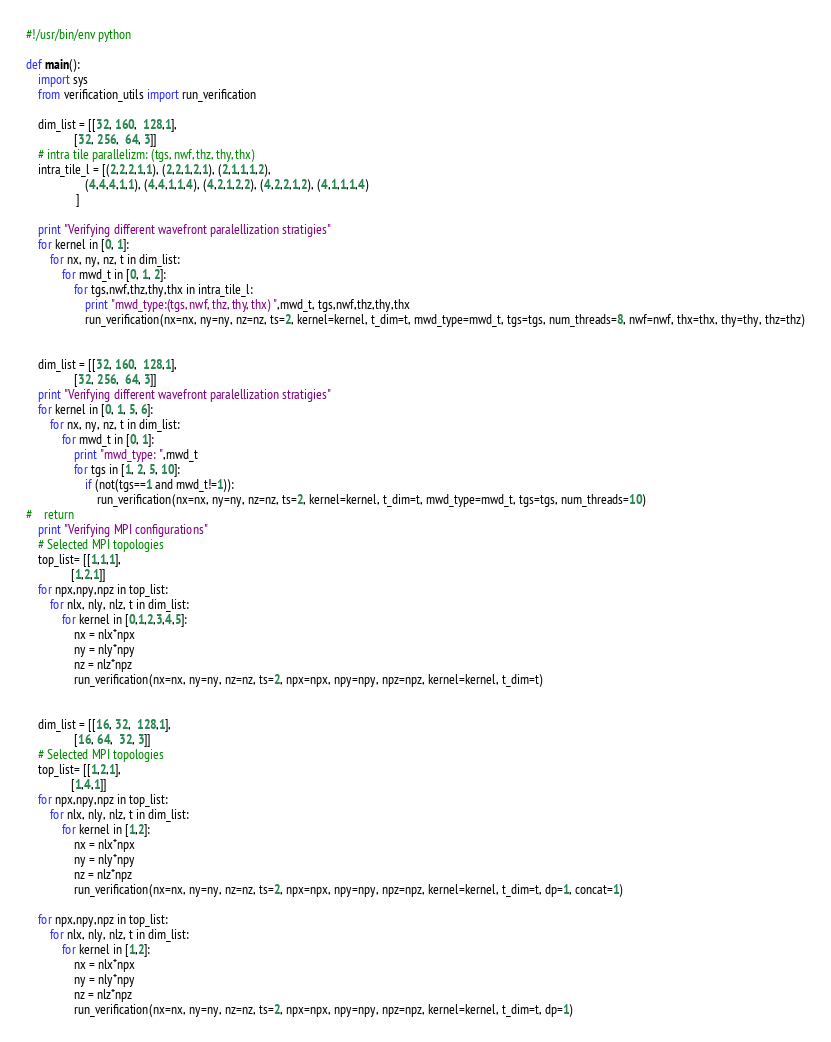<code> <loc_0><loc_0><loc_500><loc_500><_Python_>#!/usr/bin/env python

def main():
    import sys
    from verification_utils import run_verification

    dim_list = [[32, 160,  128,1],
                [32, 256,  64, 3]]
    # intra tile parallelizm: (tgs, nwf, thz, thy, thx)
    intra_tile_l = [(2,2,2,1,1), (2,2,1,2,1), (2,1,1,1,2),
                    (4,4,4,1,1), (4,4,1,1,4), (4,2,1,2,2), (4,2,2,1,2), (4,1,1,1,4)
                 ]

    print "Verifying different wavefront paralellization stratigies" 
    for kernel in [0, 1]:
        for nx, ny, nz, t in dim_list:
            for mwd_t in [0, 1, 2]:
                for tgs,nwf,thz,thy,thx in intra_tile_l:
                    print "mwd_type:(tgs, nwf, thz, thy, thx) ",mwd_t, tgs,nwf,thz,thy,thx
                    run_verification(nx=nx, ny=ny, nz=nz, ts=2, kernel=kernel, t_dim=t, mwd_type=mwd_t, tgs=tgs, num_threads=8, nwf=nwf, thx=thx, thy=thy, thz=thz)


    dim_list = [[32, 160,  128,1],
                [32, 256,  64, 3]]
    print "Verifying different wavefront paralellization stratigies" 
    for kernel in [0, 1, 5, 6]:
        for nx, ny, nz, t in dim_list:
            for mwd_t in [0, 1]:
                print "mwd_type: ",mwd_t
                for tgs in [1, 2, 5, 10]:
                    if (not(tgs==1 and mwd_t!=1)):
                        run_verification(nx=nx, ny=ny, nz=nz, ts=2, kernel=kernel, t_dim=t, mwd_type=mwd_t, tgs=tgs, num_threads=10)
#    return
    print "Verifying MPI configurations"
    # Selected MPI topologies
    top_list= [[1,1,1],
               [1,2,1]]
    for npx,npy,npz in top_list:
        for nlx, nly, nlz, t in dim_list:
            for kernel in [0,1,2,3,4,5]:
                nx = nlx*npx
                ny = nly*npy
                nz = nlz*npz
                run_verification(nx=nx, ny=ny, nz=nz, ts=2, npx=npx, npy=npy, npz=npz, kernel=kernel, t_dim=t)


    dim_list = [[16, 32,  128,1],
                [16, 64,  32, 3]]
    # Selected MPI topologies
    top_list= [[1,2,1],
               [1,4,1]]
    for npx,npy,npz in top_list:
        for nlx, nly, nlz, t in dim_list:
            for kernel in [1,2]:
                nx = nlx*npx
                ny = nly*npy
                nz = nlz*npz
                run_verification(nx=nx, ny=ny, nz=nz, ts=2, npx=npx, npy=npy, npz=npz, kernel=kernel, t_dim=t, dp=1, concat=1)

    for npx,npy,npz in top_list:
        for nlx, nly, nlz, t in dim_list:
            for kernel in [1,2]:
                nx = nlx*npx
                ny = nly*npy
                nz = nlz*npz
                run_verification(nx=nx, ny=ny, nz=nz, ts=2, npx=npx, npy=npy, npz=npz, kernel=kernel, t_dim=t, dp=1)

</code> 